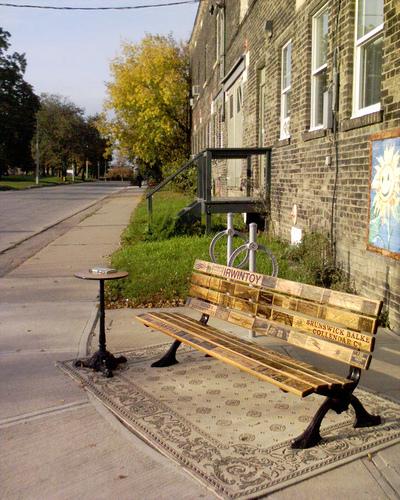What is the building made from?
Write a very short answer. Brick. What is the bench sitting on top of?
Give a very brief answer. Rug. Is it snowing?
Give a very brief answer. No. 